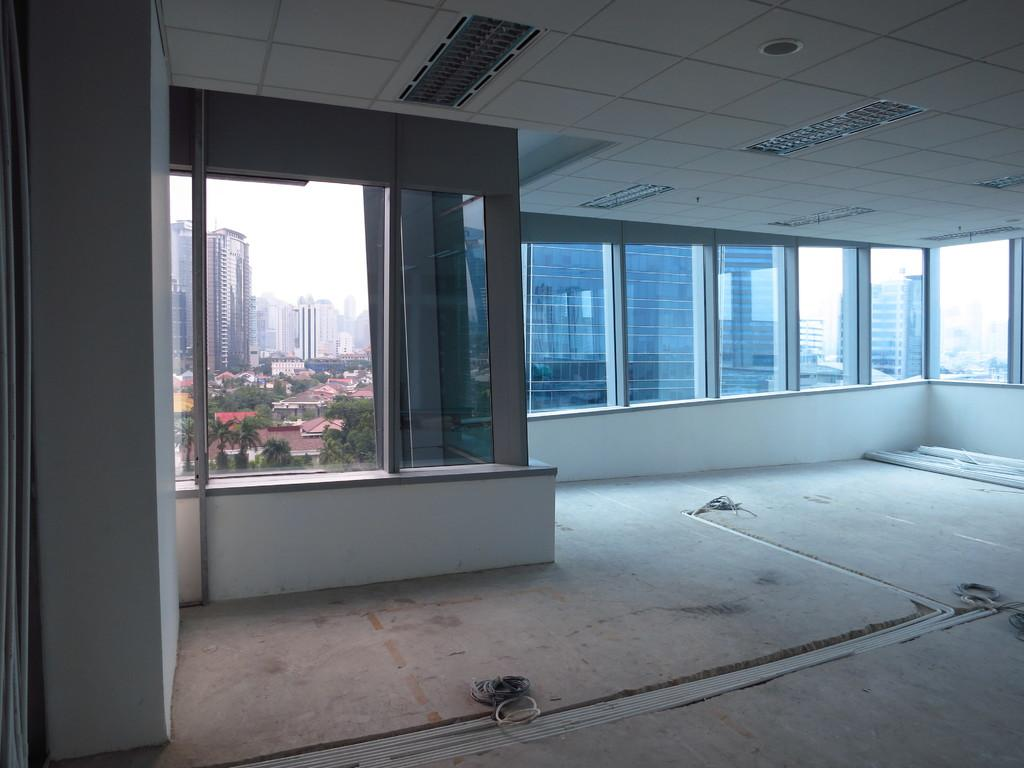What type of room is shown in the image? The image shows an inside view of a room. What feature allows natural light to enter the room? There are glass windows in the room. What can be seen outside the windows? Trees and buildings are visible through the windows. What provides artificial light in the room? There are lights on the ceiling of the room. What type of substance is being expanded by the bomb in the image? There is no substance or bomb present in the image; it shows a room with windows and lights. 